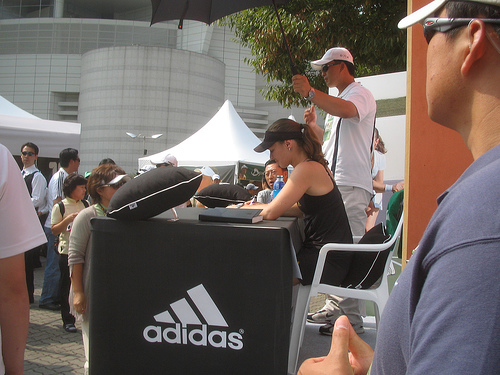<image>
Is there a lady above the table? No. The lady is not positioned above the table. The vertical arrangement shows a different relationship. Where is the woman in relation to the table? Is it above the table? No. The woman is not positioned above the table. The vertical arrangement shows a different relationship. 